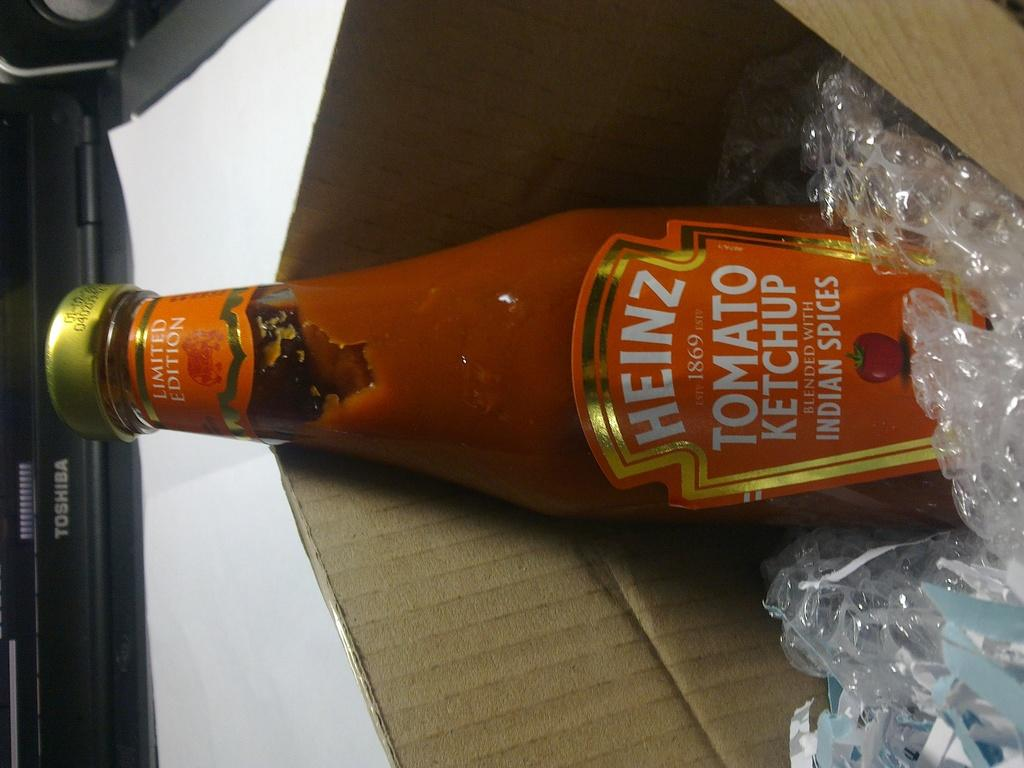<image>
Relay a brief, clear account of the picture shown. An open box with a bottle of Heinz tomato ketchup. 